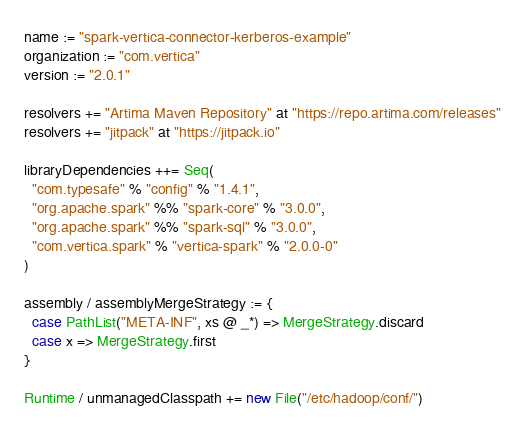<code> <loc_0><loc_0><loc_500><loc_500><_Scala_>name := "spark-vertica-connector-kerberos-example"
organization := "com.vertica"
version := "2.0.1"

resolvers += "Artima Maven Repository" at "https://repo.artima.com/releases"
resolvers += "jitpack" at "https://jitpack.io"

libraryDependencies ++= Seq(
  "com.typesafe" % "config" % "1.4.1",
  "org.apache.spark" %% "spark-core" % "3.0.0",
  "org.apache.spark" %% "spark-sql" % "3.0.0",
  "com.vertica.spark" % "vertica-spark" % "2.0.0-0"
)

assembly / assemblyMergeStrategy := {
  case PathList("META-INF", xs @ _*) => MergeStrategy.discard
  case x => MergeStrategy.first
}

Runtime / unmanagedClasspath += new File("/etc/hadoop/conf/")
</code> 